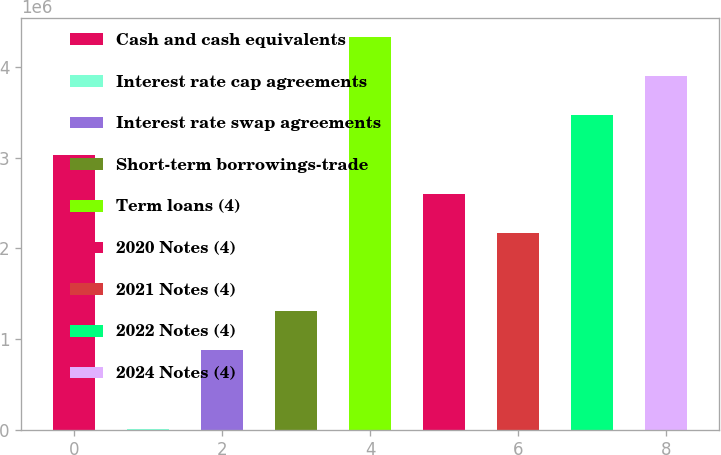Convert chart to OTSL. <chart><loc_0><loc_0><loc_500><loc_500><bar_chart><fcel>Cash and cash equivalents<fcel>Interest rate cap agreements<fcel>Interest rate swap agreements<fcel>Short-term borrowings-trade<fcel>Term loans (4)<fcel>2020 Notes (4)<fcel>2021 Notes (4)<fcel>2022 Notes (4)<fcel>2024 Notes (4)<nl><fcel>3.03603e+06<fcel>8180<fcel>873280<fcel>1.30583e+06<fcel>4.33368e+06<fcel>2.60348e+06<fcel>2.17093e+06<fcel>3.46858e+06<fcel>3.90113e+06<nl></chart> 